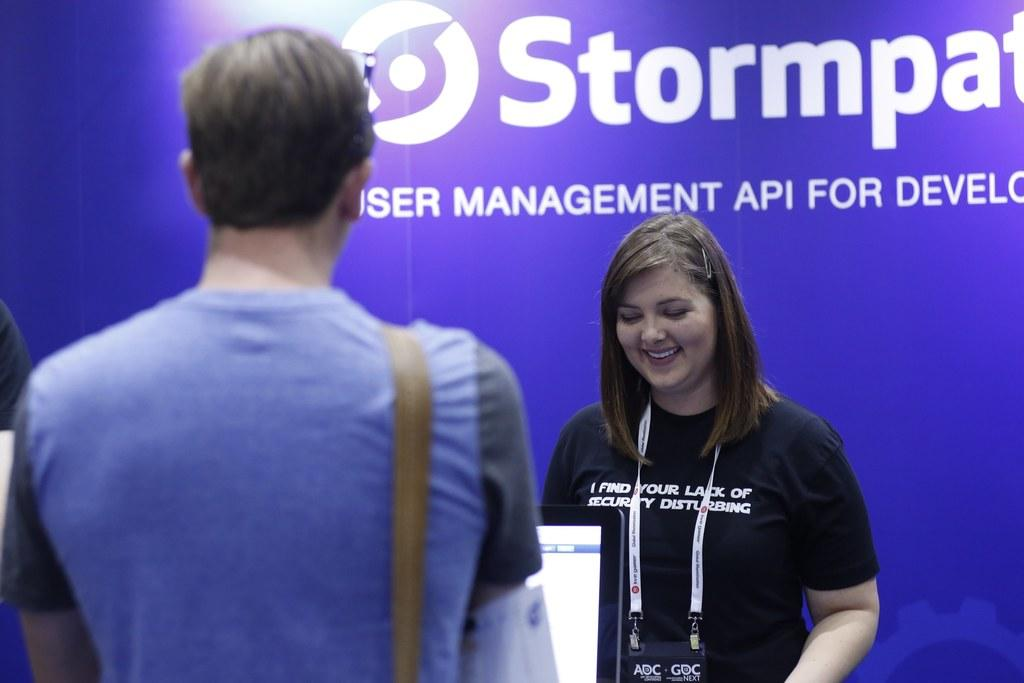Who is the main subject on the left side of the image? There is a man on the left side of the image. What is the man's position in relation to the screen? The screen is in front of the man. Who is the other person in the image? There is a lady in the image. Where is the lady located in the image? A: The lady is on the right side of the image. What is the lady's expression in the image? The lady is smiling in the image. What is the lady wearing in the image? The lady is wearing a black t-shirt in the image. What can be seen in the background of the image? There is a banner in the background of the image. What type of yam is being used for the science experiment in the image? There is no yam or science experiment present in the image. How does the lady shake hands with the man in the image? There is no handshake depicted in the image; the lady is smiling and standing on the right side, while the man is on the left side with a screen in front of him. 